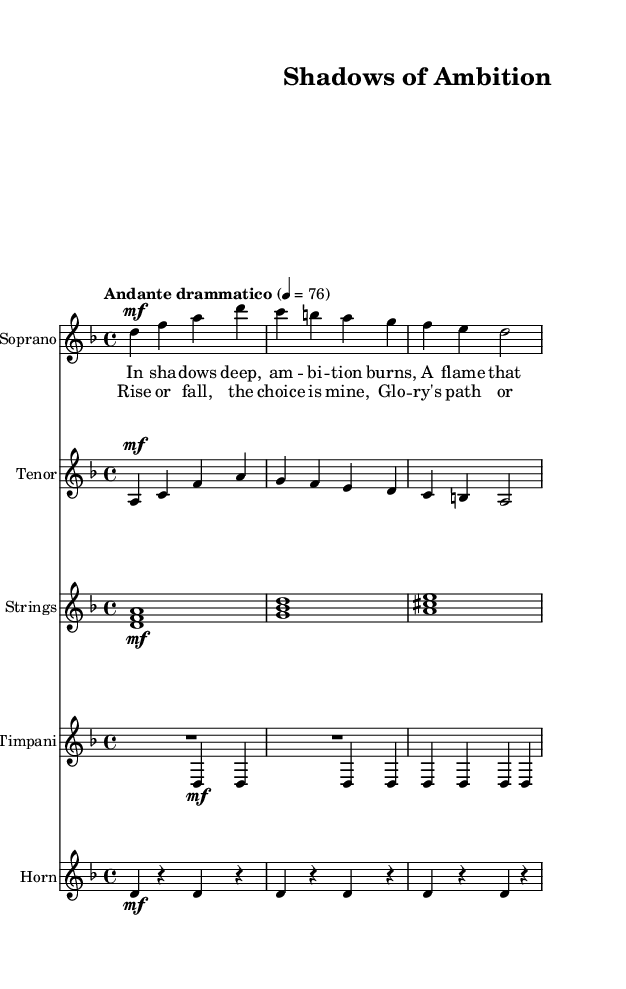What is the key signature of this music? The key signature is indicated at the beginning of the score, and it shows two flats. The context of the music piece is in D minor.
Answer: D minor What is the time signature of this piece? The time signature is typically found at the beginning of the score. Here, the time signature shows a 4/4, which means there are four beats in each measure.
Answer: 4/4 What is the tempo marking of the score? The tempo marking is usually placed at the start of the score, indicating the speed. The marking here is "Andante drammatico," which suggests a moderately slow, dramatic pace.
Answer: Andante drammatico What instruments are featured in this opera score? The instruments are listed at the beginning of each staff. In this score, we have Soprano, Tenor, Strings, Timpani, and Horn.
Answer: Soprano, Tenor, Strings, Timpani, Horn Which voice part starts the score? The order of the staff from top to bottom shows that the Soprano part is the first voice listed, indicating it's the leading voice in the arrangement.
Answer: Soprano What is the significance of the lyrics "In sha -- dows deep, am -- bi -- tion burns"? The lyrics express the central theme of ambition that is explored in this dramatic opera. It suggests a personal struggle with rivalry and longing for glory, fitting within the narrative context of the performance.
Answer: Ambition 